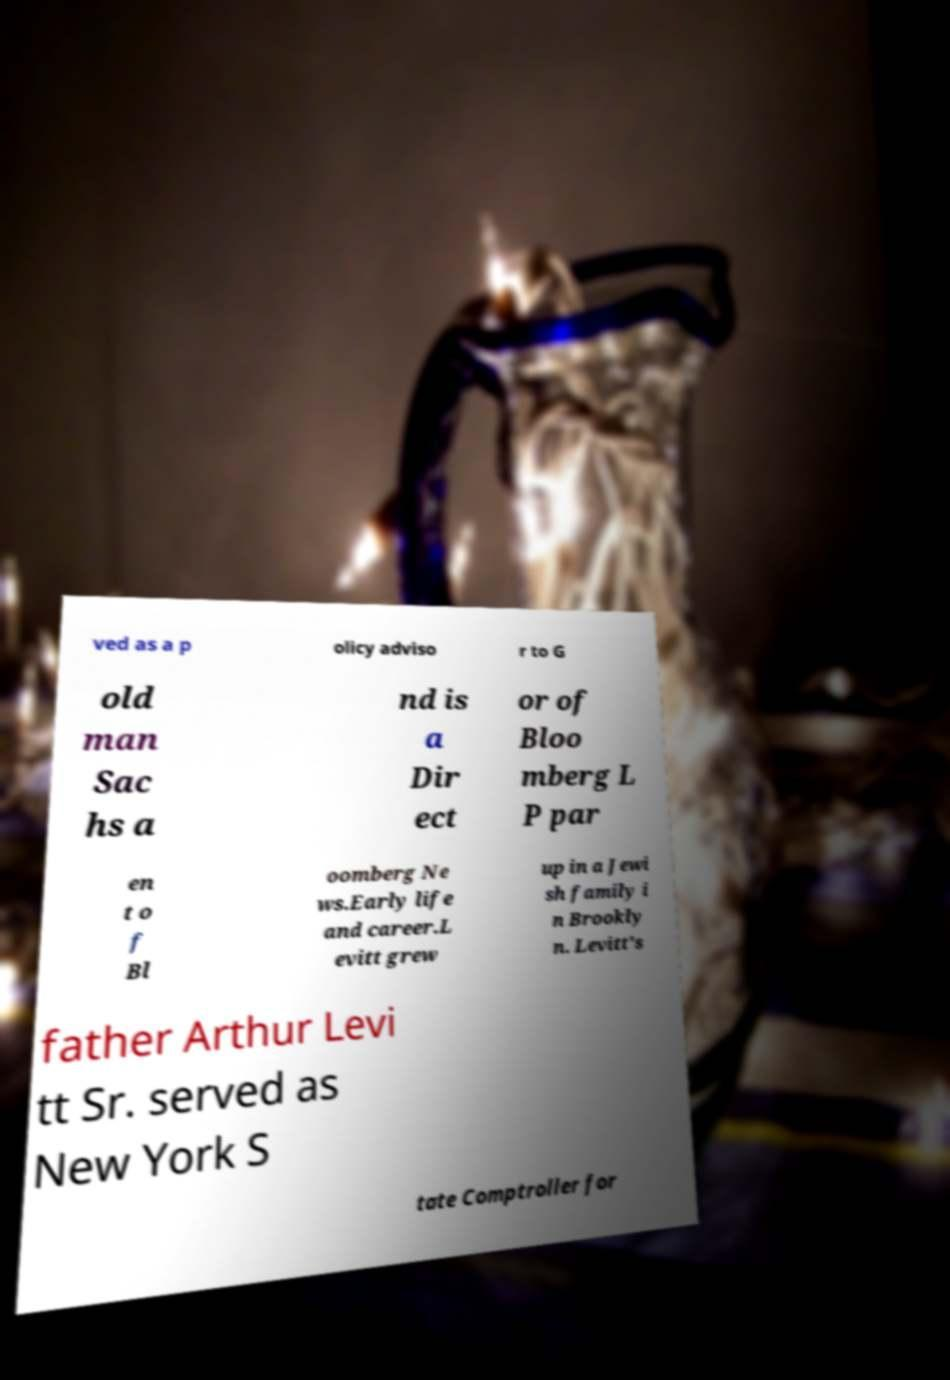Can you accurately transcribe the text from the provided image for me? ved as a p olicy adviso r to G old man Sac hs a nd is a Dir ect or of Bloo mberg L P par en t o f Bl oomberg Ne ws.Early life and career.L evitt grew up in a Jewi sh family i n Brookly n. Levitt's father Arthur Levi tt Sr. served as New York S tate Comptroller for 